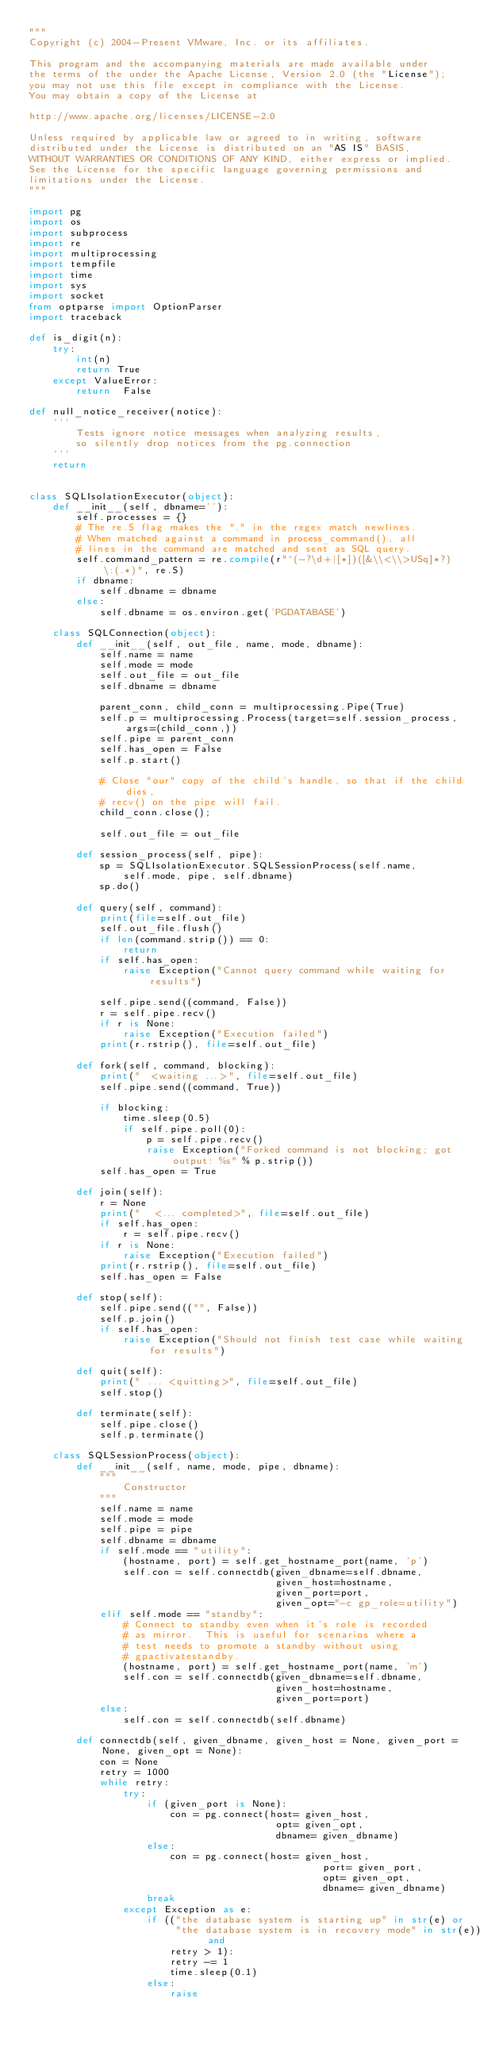Convert code to text. <code><loc_0><loc_0><loc_500><loc_500><_Python_>"""
Copyright (c) 2004-Present VMware, Inc. or its affiliates.

This program and the accompanying materials are made available under
the terms of the under the Apache License, Version 2.0 (the "License");
you may not use this file except in compliance with the License.
You may obtain a copy of the License at

http://www.apache.org/licenses/LICENSE-2.0

Unless required by applicable law or agreed to in writing, software
distributed under the License is distributed on an "AS IS" BASIS,
WITHOUT WARRANTIES OR CONDITIONS OF ANY KIND, either express or implied.
See the License for the specific language governing permissions and
limitations under the License.
"""

import pg
import os
import subprocess
import re
import multiprocessing
import tempfile
import time
import sys
import socket
from optparse import OptionParser
import traceback

def is_digit(n):
    try:
        int(n)
        return True
    except ValueError:
        return  False

def null_notice_receiver(notice):
    '''
        Tests ignore notice messages when analyzing results,
        so silently drop notices from the pg.connection
    '''
    return


class SQLIsolationExecutor(object):
    def __init__(self, dbname=''):
        self.processes = {}
        # The re.S flag makes the "." in the regex match newlines.
        # When matched against a command in process_command(), all
        # lines in the command are matched and sent as SQL query.
        self.command_pattern = re.compile(r"^(-?\d+|[*])([&\\<\\>USq]*?)\:(.*)", re.S)
        if dbname:
            self.dbname = dbname
        else:
            self.dbname = os.environ.get('PGDATABASE')

    class SQLConnection(object):
        def __init__(self, out_file, name, mode, dbname):
            self.name = name
            self.mode = mode
            self.out_file = out_file
            self.dbname = dbname

            parent_conn, child_conn = multiprocessing.Pipe(True)
            self.p = multiprocessing.Process(target=self.session_process, args=(child_conn,))   
            self.pipe = parent_conn
            self.has_open = False
            self.p.start()

            # Close "our" copy of the child's handle, so that if the child dies,
            # recv() on the pipe will fail.
            child_conn.close();

            self.out_file = out_file

        def session_process(self, pipe):
            sp = SQLIsolationExecutor.SQLSessionProcess(self.name, 
                self.mode, pipe, self.dbname)
            sp.do()

        def query(self, command):
            print(file=self.out_file)
            self.out_file.flush()
            if len(command.strip()) == 0:
                return
            if self.has_open:
                raise Exception("Cannot query command while waiting for results")

            self.pipe.send((command, False))
            r = self.pipe.recv()
            if r is None:
                raise Exception("Execution failed")
            print(r.rstrip(), file=self.out_file)

        def fork(self, command, blocking):
            print("  <waiting ...>", file=self.out_file)
            self.pipe.send((command, True))

            if blocking:
                time.sleep(0.5)
                if self.pipe.poll(0):
                    p = self.pipe.recv()
                    raise Exception("Forked command is not blocking; got output: %s" % p.strip())
            self.has_open = True

        def join(self):
            r = None
            print("  <... completed>", file=self.out_file)
            if self.has_open:
                r = self.pipe.recv()
            if r is None:
                raise Exception("Execution failed")
            print(r.rstrip(), file=self.out_file)
            self.has_open = False

        def stop(self):
            self.pipe.send(("", False))
            self.p.join()
            if self.has_open:
                raise Exception("Should not finish test case while waiting for results")

        def quit(self):
            print(" ... <quitting>", file=self.out_file)
            self.stop()
        
        def terminate(self):
            self.pipe.close()
            self.p.terminate()

    class SQLSessionProcess(object):
        def __init__(self, name, mode, pipe, dbname):
            """
                Constructor
            """
            self.name = name
            self.mode = mode
            self.pipe = pipe
            self.dbname = dbname
            if self.mode == "utility":
                (hostname, port) = self.get_hostname_port(name, 'p')
                self.con = self.connectdb(given_dbname=self.dbname,
                                          given_host=hostname,
                                          given_port=port,
                                          given_opt="-c gp_role=utility")
            elif self.mode == "standby":
                # Connect to standby even when it's role is recorded
                # as mirror.  This is useful for scenarios where a
                # test needs to promote a standby without using
                # gpactivatestandby.
                (hostname, port) = self.get_hostname_port(name, 'm')
                self.con = self.connectdb(given_dbname=self.dbname,
                                          given_host=hostname,
                                          given_port=port)
            else:
                self.con = self.connectdb(self.dbname)

        def connectdb(self, given_dbname, given_host = None, given_port = None, given_opt = None):
            con = None
            retry = 1000
            while retry:
                try:
                    if (given_port is None):
                        con = pg.connect(host= given_host,
                                          opt= given_opt,
                                          dbname= given_dbname)
                    else:
                        con = pg.connect(host= given_host,
                                                  port= given_port,
                                                  opt= given_opt,
                                                  dbname= given_dbname)
                    break
                except Exception as e:
                    if (("the database system is starting up" in str(e) or
                         "the database system is in recovery mode" in str(e)) and
                        retry > 1):
                        retry -= 1
                        time.sleep(0.1)
                    else:
                        raise</code> 